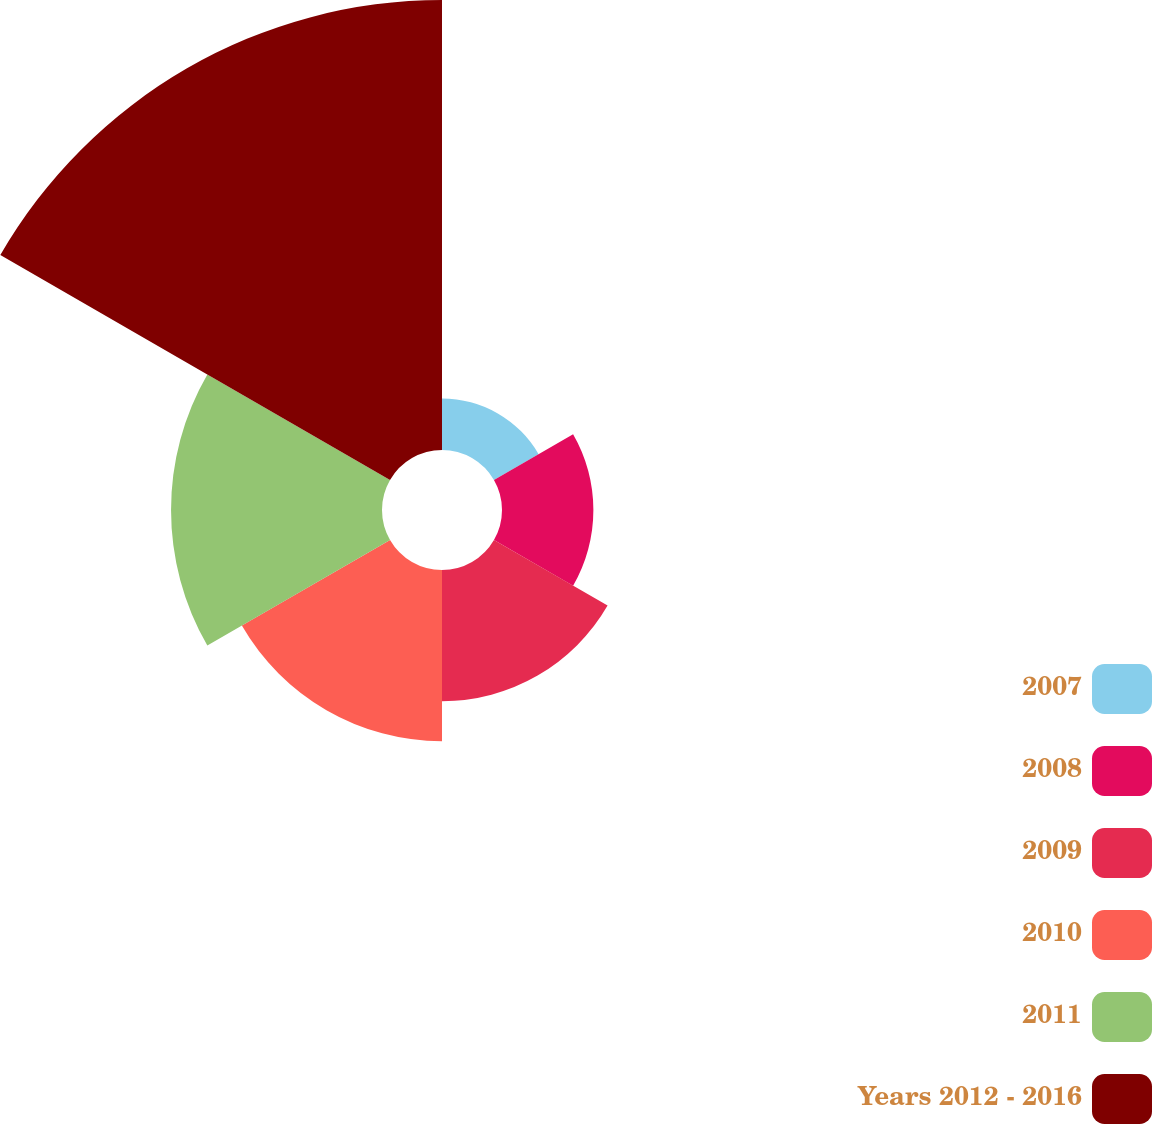Convert chart. <chart><loc_0><loc_0><loc_500><loc_500><pie_chart><fcel>2007<fcel>2008<fcel>2009<fcel>2010<fcel>2011<fcel>Years 2012 - 2016<nl><fcel>4.66%<fcel>8.26%<fcel>11.86%<fcel>15.47%<fcel>19.07%<fcel>40.68%<nl></chart> 